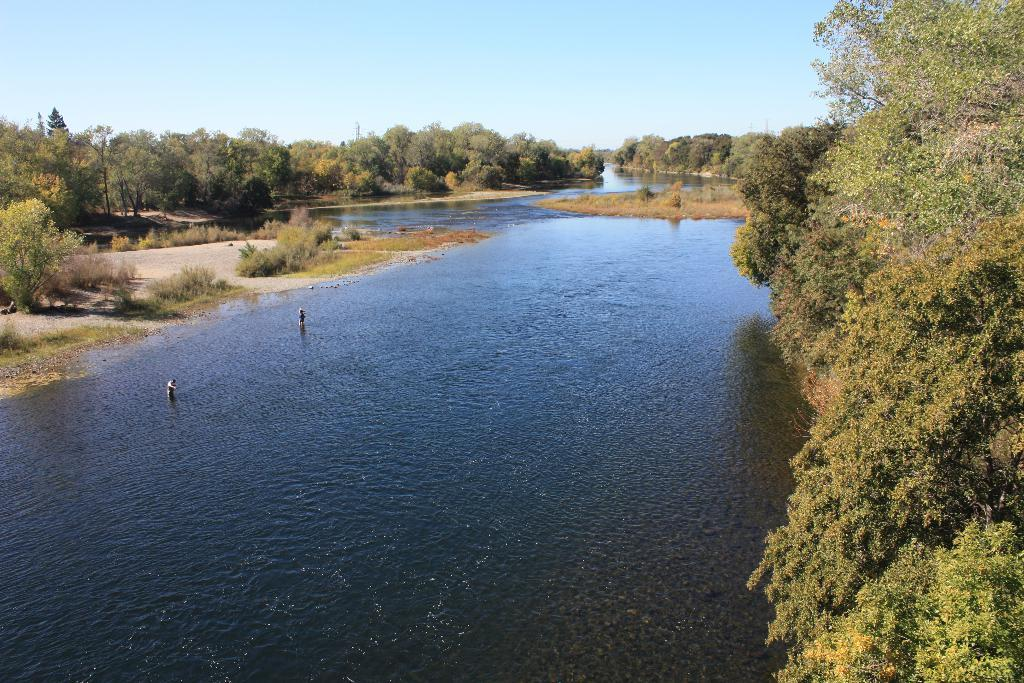What type of vegetation can be seen in the image? There are trees in the image. Who or what else is present in the image? There are people in the image. What natural element is visible in the image? There is water visible in the image. What is visible at the top of the image? The sky is visible at the top of the image. What type of jeans is the ant wearing in the image? There is no ant or jeans present in the image. What knowledge can be gained from the image? The image provides information about the presence of trees, people, water, and the sky, but it does not convey any specific knowledge or lesson. 